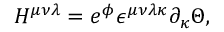<formula> <loc_0><loc_0><loc_500><loc_500>H ^ { \mu \nu \lambda } = e ^ { \phi } \epsilon ^ { \mu \nu \lambda \kappa } \partial _ { \kappa } \Theta ,</formula> 